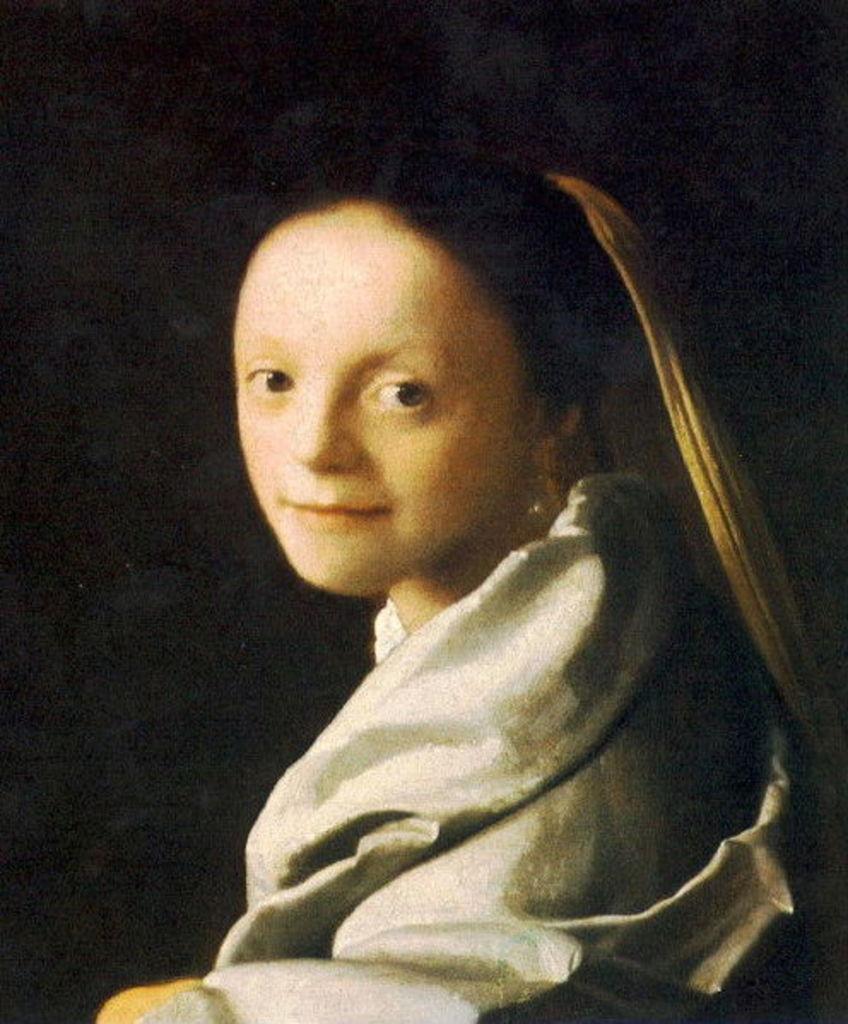Describe this image in one or two sentences. In this picture I can see the painting. In the center I can see the painting of a woman who is wearing white dress. In the back I can see the darkness. 